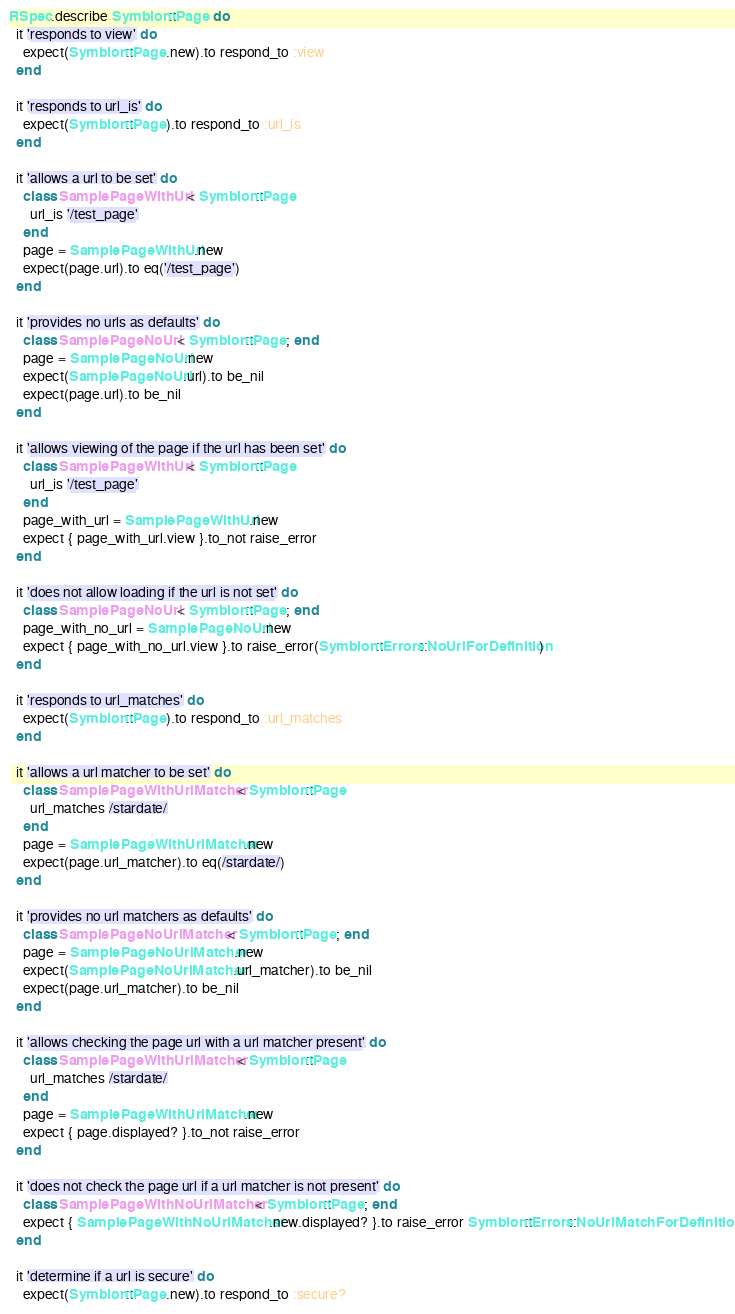<code> <loc_0><loc_0><loc_500><loc_500><_Ruby_>RSpec.describe Symbiont::Page do
  it 'responds to view' do
    expect(Symbiont::Page.new).to respond_to :view
  end

  it 'responds to url_is' do
    expect(Symbiont::Page).to respond_to :url_is
  end

  it 'allows a url to be set' do
    class SamplePageWithUrl < Symbiont::Page
      url_is '/test_page'
    end
    page = SamplePageWithUrl.new
    expect(page.url).to eq('/test_page')
  end

  it 'provides no urls as defaults' do
    class SamplePageNoUrl < Symbiont::Page; end
    page = SamplePageNoUrl.new
    expect(SamplePageNoUrl.url).to be_nil
    expect(page.url).to be_nil
  end

  it 'allows viewing of the page if the url has been set' do
    class SamplePageWithUrl < Symbiont::Page
      url_is '/test_page'
    end
    page_with_url = SamplePageWithUrl.new
    expect { page_with_url.view }.to_not raise_error
  end

  it 'does not allow loading if the url is not set' do
    class SamplePageNoUrl < Symbiont::Page; end
    page_with_no_url = SamplePageNoUrl.new
    expect { page_with_no_url.view }.to raise_error(Symbiont::Errors::NoUrlForDefinition)
  end

  it 'responds to url_matches' do
    expect(Symbiont::Page).to respond_to :url_matches
  end

  it 'allows a url matcher to be set' do
    class SamplePageWithUrlMatcher < Symbiont::Page
      url_matches /stardate/
    end
    page = SamplePageWithUrlMatcher.new
    expect(page.url_matcher).to eq(/stardate/)
  end

  it 'provides no url matchers as defaults' do
    class SamplePageNoUrlMatcher < Symbiont::Page; end
    page = SamplePageNoUrlMatcher.new
    expect(SamplePageNoUrlMatcher.url_matcher).to be_nil
    expect(page.url_matcher).to be_nil
  end

  it 'allows checking the page url with a url matcher present' do
    class SamplePageWithUrlMatcher < Symbiont::Page
      url_matches /stardate/
    end
    page = SamplePageWithUrlMatcher.new
    expect { page.displayed? }.to_not raise_error
  end

  it 'does not check the page url if a url matcher is not present' do
    class SamplePageWithNoUrlMatcher < Symbiont::Page; end
    expect { SamplePageWithNoUrlMatcher.new.displayed? }.to raise_error Symbiont::Errors::NoUrlMatchForDefinition
  end

  it 'determine if a url is secure' do
    expect(Symbiont::Page.new).to respond_to :secure?</code> 